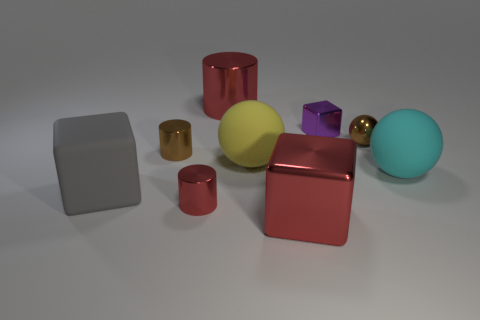Subtract 1 blocks. How many blocks are left? 2 Subtract all cylinders. How many objects are left? 6 Add 1 brown spheres. How many brown spheres exist? 2 Subtract 1 yellow balls. How many objects are left? 8 Subtract all large cylinders. Subtract all small spheres. How many objects are left? 7 Add 2 gray things. How many gray things are left? 3 